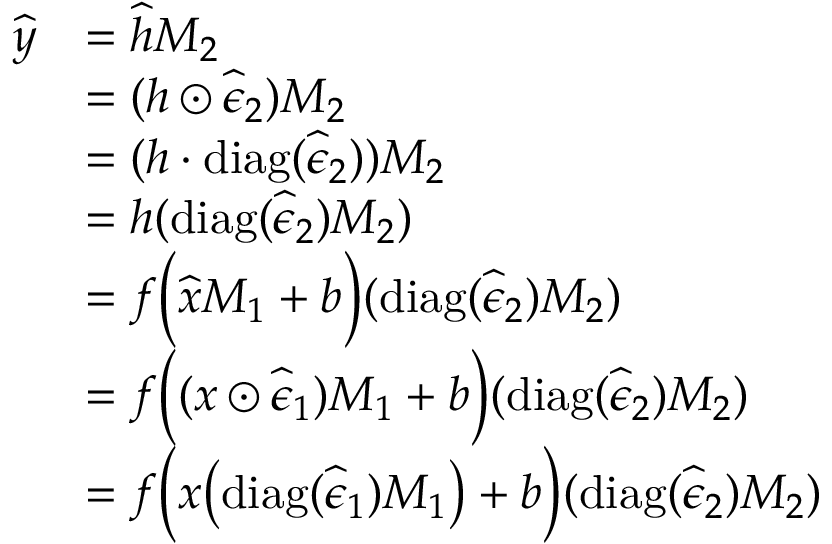<formula> <loc_0><loc_0><loc_500><loc_500>\begin{array} { r l } { \widehat { y } } & { = \widehat { h } M _ { 2 } } \\ & { = ( h \odot \widehat { \epsilon } _ { 2 } ) M _ { 2 } } \\ & { = ( h \cdot d i a g ( \widehat { \epsilon } _ { 2 } ) ) M _ { 2 } } \\ & { = h ( d i a g ( \widehat { \epsilon } _ { 2 } ) M _ { 2 } ) } \\ & { = f \left ( \widehat { x } M _ { 1 } + b \right ) ( d i a g ( \widehat { \epsilon } _ { 2 } ) M _ { 2 } ) } \\ & { = f \left ( ( x \odot \widehat { \epsilon } _ { 1 } ) M _ { 1 } + b \right ) ( d i a g ( \widehat { \epsilon } _ { 2 } ) M _ { 2 } ) } \\ & { = f \left ( x \left ( d i a g ( \widehat { \epsilon } _ { 1 } ) M _ { 1 } \right ) + b \right ) ( d i a g ( \widehat { \epsilon } _ { 2 } ) M _ { 2 } ) } \end{array}</formula> 